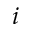Convert formula to latex. <formula><loc_0><loc_0><loc_500><loc_500>i</formula> 